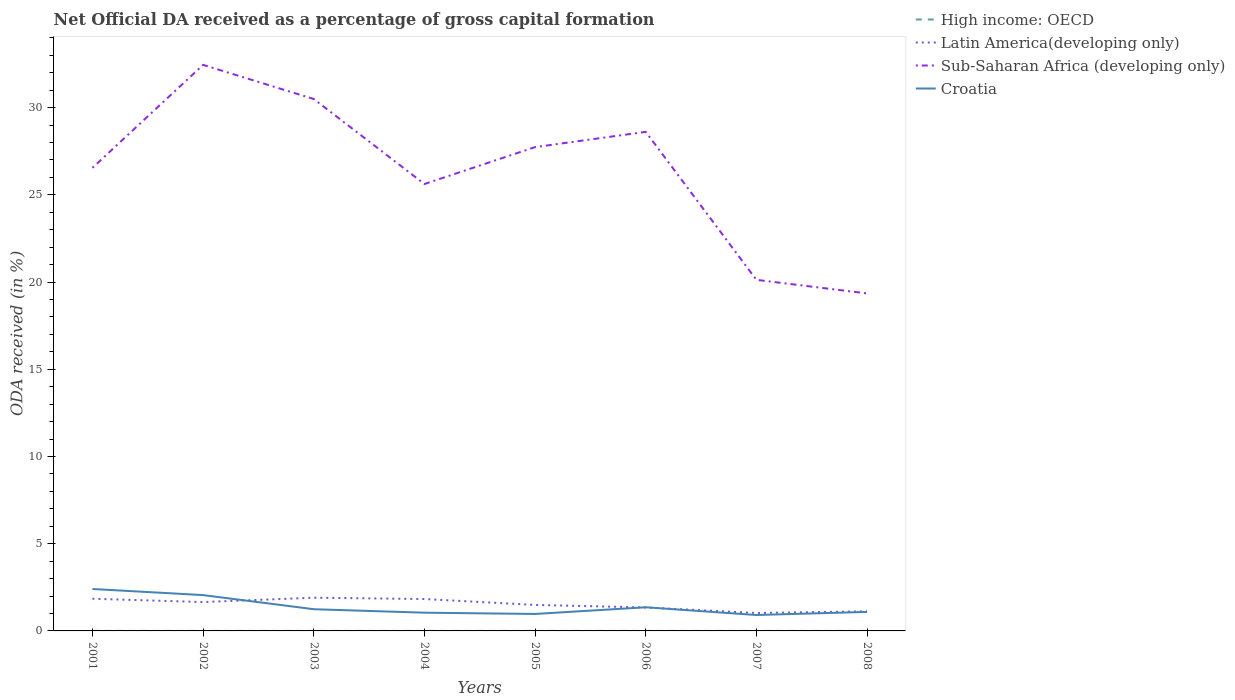How many different coloured lines are there?
Ensure brevity in your answer.  4. Is the number of lines equal to the number of legend labels?
Offer a terse response. Yes. Across all years, what is the maximum net ODA received in Croatia?
Provide a short and direct response. 0.91. In which year was the net ODA received in Latin America(developing only) maximum?
Make the answer very short. 2007. What is the total net ODA received in Croatia in the graph?
Your answer should be compact. 0.35. What is the difference between the highest and the second highest net ODA received in Latin America(developing only)?
Your answer should be compact. 0.88. Is the net ODA received in Croatia strictly greater than the net ODA received in Latin America(developing only) over the years?
Provide a short and direct response. No. How many years are there in the graph?
Keep it short and to the point. 8. What is the difference between two consecutive major ticks on the Y-axis?
Provide a short and direct response. 5. Are the values on the major ticks of Y-axis written in scientific E-notation?
Your response must be concise. No. Where does the legend appear in the graph?
Make the answer very short. Top right. What is the title of the graph?
Offer a very short reply. Net Official DA received as a percentage of gross capital formation. Does "Estonia" appear as one of the legend labels in the graph?
Give a very brief answer. No. What is the label or title of the X-axis?
Provide a short and direct response. Years. What is the label or title of the Y-axis?
Ensure brevity in your answer.  ODA received (in %). What is the ODA received (in %) in High income: OECD in 2001?
Ensure brevity in your answer.  0. What is the ODA received (in %) in Latin America(developing only) in 2001?
Provide a short and direct response. 1.84. What is the ODA received (in %) of Sub-Saharan Africa (developing only) in 2001?
Offer a terse response. 26.55. What is the ODA received (in %) of Croatia in 2001?
Give a very brief answer. 2.4. What is the ODA received (in %) in High income: OECD in 2002?
Offer a terse response. 0. What is the ODA received (in %) in Latin America(developing only) in 2002?
Your response must be concise. 1.65. What is the ODA received (in %) in Sub-Saharan Africa (developing only) in 2002?
Your answer should be very brief. 32.45. What is the ODA received (in %) in Croatia in 2002?
Give a very brief answer. 2.05. What is the ODA received (in %) of High income: OECD in 2003?
Offer a terse response. 0. What is the ODA received (in %) of Latin America(developing only) in 2003?
Offer a very short reply. 1.9. What is the ODA received (in %) of Sub-Saharan Africa (developing only) in 2003?
Offer a terse response. 30.5. What is the ODA received (in %) in Croatia in 2003?
Ensure brevity in your answer.  1.24. What is the ODA received (in %) of High income: OECD in 2004?
Your response must be concise. 0. What is the ODA received (in %) in Latin America(developing only) in 2004?
Offer a very short reply. 1.83. What is the ODA received (in %) in Sub-Saharan Africa (developing only) in 2004?
Keep it short and to the point. 25.62. What is the ODA received (in %) of Croatia in 2004?
Provide a short and direct response. 1.05. What is the ODA received (in %) of High income: OECD in 2005?
Your answer should be very brief. 0. What is the ODA received (in %) of Latin America(developing only) in 2005?
Your response must be concise. 1.49. What is the ODA received (in %) in Sub-Saharan Africa (developing only) in 2005?
Your response must be concise. 27.74. What is the ODA received (in %) in Croatia in 2005?
Give a very brief answer. 0.97. What is the ODA received (in %) of High income: OECD in 2006?
Your response must be concise. 0. What is the ODA received (in %) of Latin America(developing only) in 2006?
Offer a terse response. 1.34. What is the ODA received (in %) of Sub-Saharan Africa (developing only) in 2006?
Your answer should be compact. 28.61. What is the ODA received (in %) in Croatia in 2006?
Offer a terse response. 1.36. What is the ODA received (in %) of High income: OECD in 2007?
Your response must be concise. 0. What is the ODA received (in %) in Latin America(developing only) in 2007?
Your response must be concise. 1.03. What is the ODA received (in %) in Sub-Saharan Africa (developing only) in 2007?
Offer a terse response. 20.13. What is the ODA received (in %) of Croatia in 2007?
Your response must be concise. 0.91. What is the ODA received (in %) in High income: OECD in 2008?
Your answer should be very brief. 0. What is the ODA received (in %) of Latin America(developing only) in 2008?
Offer a very short reply. 1.12. What is the ODA received (in %) of Sub-Saharan Africa (developing only) in 2008?
Make the answer very short. 19.35. What is the ODA received (in %) in Croatia in 2008?
Your answer should be compact. 1.09. Across all years, what is the maximum ODA received (in %) in High income: OECD?
Give a very brief answer. 0. Across all years, what is the maximum ODA received (in %) of Latin America(developing only)?
Ensure brevity in your answer.  1.9. Across all years, what is the maximum ODA received (in %) in Sub-Saharan Africa (developing only)?
Give a very brief answer. 32.45. Across all years, what is the maximum ODA received (in %) in Croatia?
Provide a succinct answer. 2.4. Across all years, what is the minimum ODA received (in %) of High income: OECD?
Offer a terse response. 0. Across all years, what is the minimum ODA received (in %) of Latin America(developing only)?
Give a very brief answer. 1.03. Across all years, what is the minimum ODA received (in %) in Sub-Saharan Africa (developing only)?
Provide a succinct answer. 19.35. Across all years, what is the minimum ODA received (in %) in Croatia?
Offer a terse response. 0.91. What is the total ODA received (in %) in High income: OECD in the graph?
Your response must be concise. 0.01. What is the total ODA received (in %) of Latin America(developing only) in the graph?
Offer a terse response. 12.22. What is the total ODA received (in %) of Sub-Saharan Africa (developing only) in the graph?
Provide a succinct answer. 210.94. What is the total ODA received (in %) of Croatia in the graph?
Keep it short and to the point. 11.08. What is the difference between the ODA received (in %) of High income: OECD in 2001 and that in 2002?
Your answer should be compact. 0. What is the difference between the ODA received (in %) in Latin America(developing only) in 2001 and that in 2002?
Keep it short and to the point. 0.19. What is the difference between the ODA received (in %) in Sub-Saharan Africa (developing only) in 2001 and that in 2002?
Your answer should be compact. -5.9. What is the difference between the ODA received (in %) of Croatia in 2001 and that in 2002?
Offer a terse response. 0.35. What is the difference between the ODA received (in %) of High income: OECD in 2001 and that in 2003?
Your answer should be very brief. 0. What is the difference between the ODA received (in %) in Latin America(developing only) in 2001 and that in 2003?
Ensure brevity in your answer.  -0.06. What is the difference between the ODA received (in %) in Sub-Saharan Africa (developing only) in 2001 and that in 2003?
Keep it short and to the point. -3.95. What is the difference between the ODA received (in %) in Croatia in 2001 and that in 2003?
Your response must be concise. 1.16. What is the difference between the ODA received (in %) of High income: OECD in 2001 and that in 2004?
Provide a short and direct response. 0. What is the difference between the ODA received (in %) of Latin America(developing only) in 2001 and that in 2004?
Ensure brevity in your answer.  0.02. What is the difference between the ODA received (in %) of Sub-Saharan Africa (developing only) in 2001 and that in 2004?
Give a very brief answer. 0.93. What is the difference between the ODA received (in %) of Croatia in 2001 and that in 2004?
Offer a terse response. 1.36. What is the difference between the ODA received (in %) of High income: OECD in 2001 and that in 2005?
Provide a succinct answer. 0. What is the difference between the ODA received (in %) in Latin America(developing only) in 2001 and that in 2005?
Your answer should be compact. 0.35. What is the difference between the ODA received (in %) of Sub-Saharan Africa (developing only) in 2001 and that in 2005?
Give a very brief answer. -1.19. What is the difference between the ODA received (in %) in Croatia in 2001 and that in 2005?
Provide a short and direct response. 1.43. What is the difference between the ODA received (in %) in High income: OECD in 2001 and that in 2006?
Keep it short and to the point. 0. What is the difference between the ODA received (in %) of Sub-Saharan Africa (developing only) in 2001 and that in 2006?
Provide a succinct answer. -2.06. What is the difference between the ODA received (in %) in Croatia in 2001 and that in 2006?
Offer a very short reply. 1.05. What is the difference between the ODA received (in %) in High income: OECD in 2001 and that in 2007?
Provide a succinct answer. 0. What is the difference between the ODA received (in %) in Latin America(developing only) in 2001 and that in 2007?
Provide a succinct answer. 0.82. What is the difference between the ODA received (in %) in Sub-Saharan Africa (developing only) in 2001 and that in 2007?
Make the answer very short. 6.42. What is the difference between the ODA received (in %) of Croatia in 2001 and that in 2007?
Provide a succinct answer. 1.49. What is the difference between the ODA received (in %) in High income: OECD in 2001 and that in 2008?
Offer a terse response. 0. What is the difference between the ODA received (in %) of Latin America(developing only) in 2001 and that in 2008?
Make the answer very short. 0.72. What is the difference between the ODA received (in %) in Sub-Saharan Africa (developing only) in 2001 and that in 2008?
Provide a succinct answer. 7.2. What is the difference between the ODA received (in %) in Croatia in 2001 and that in 2008?
Your answer should be compact. 1.31. What is the difference between the ODA received (in %) in High income: OECD in 2002 and that in 2003?
Your answer should be compact. -0. What is the difference between the ODA received (in %) in Latin America(developing only) in 2002 and that in 2003?
Give a very brief answer. -0.25. What is the difference between the ODA received (in %) in Sub-Saharan Africa (developing only) in 2002 and that in 2003?
Offer a very short reply. 1.96. What is the difference between the ODA received (in %) of Croatia in 2002 and that in 2003?
Keep it short and to the point. 0.81. What is the difference between the ODA received (in %) in High income: OECD in 2002 and that in 2004?
Make the answer very short. 0. What is the difference between the ODA received (in %) of Latin America(developing only) in 2002 and that in 2004?
Provide a succinct answer. -0.17. What is the difference between the ODA received (in %) of Sub-Saharan Africa (developing only) in 2002 and that in 2004?
Give a very brief answer. 6.83. What is the difference between the ODA received (in %) in Croatia in 2002 and that in 2004?
Keep it short and to the point. 1.01. What is the difference between the ODA received (in %) in High income: OECD in 2002 and that in 2005?
Provide a short and direct response. -0. What is the difference between the ODA received (in %) of Latin America(developing only) in 2002 and that in 2005?
Your response must be concise. 0.16. What is the difference between the ODA received (in %) of Sub-Saharan Africa (developing only) in 2002 and that in 2005?
Offer a very short reply. 4.71. What is the difference between the ODA received (in %) of Croatia in 2002 and that in 2005?
Offer a terse response. 1.08. What is the difference between the ODA received (in %) of High income: OECD in 2002 and that in 2006?
Provide a succinct answer. -0. What is the difference between the ODA received (in %) in Latin America(developing only) in 2002 and that in 2006?
Make the answer very short. 0.31. What is the difference between the ODA received (in %) of Sub-Saharan Africa (developing only) in 2002 and that in 2006?
Keep it short and to the point. 3.84. What is the difference between the ODA received (in %) of Croatia in 2002 and that in 2006?
Provide a succinct answer. 0.7. What is the difference between the ODA received (in %) of High income: OECD in 2002 and that in 2007?
Offer a very short reply. -0. What is the difference between the ODA received (in %) in Latin America(developing only) in 2002 and that in 2007?
Your response must be concise. 0.63. What is the difference between the ODA received (in %) of Sub-Saharan Africa (developing only) in 2002 and that in 2007?
Keep it short and to the point. 12.32. What is the difference between the ODA received (in %) in Croatia in 2002 and that in 2007?
Offer a very short reply. 1.14. What is the difference between the ODA received (in %) in High income: OECD in 2002 and that in 2008?
Make the answer very short. -0. What is the difference between the ODA received (in %) in Latin America(developing only) in 2002 and that in 2008?
Offer a terse response. 0.53. What is the difference between the ODA received (in %) of Sub-Saharan Africa (developing only) in 2002 and that in 2008?
Your answer should be very brief. 13.1. What is the difference between the ODA received (in %) of Croatia in 2002 and that in 2008?
Offer a very short reply. 0.96. What is the difference between the ODA received (in %) of High income: OECD in 2003 and that in 2004?
Your answer should be very brief. 0. What is the difference between the ODA received (in %) in Latin America(developing only) in 2003 and that in 2004?
Keep it short and to the point. 0.08. What is the difference between the ODA received (in %) in Sub-Saharan Africa (developing only) in 2003 and that in 2004?
Your answer should be very brief. 4.87. What is the difference between the ODA received (in %) of Croatia in 2003 and that in 2004?
Offer a terse response. 0.2. What is the difference between the ODA received (in %) of High income: OECD in 2003 and that in 2005?
Offer a terse response. -0. What is the difference between the ODA received (in %) of Latin America(developing only) in 2003 and that in 2005?
Provide a short and direct response. 0.41. What is the difference between the ODA received (in %) in Sub-Saharan Africa (developing only) in 2003 and that in 2005?
Keep it short and to the point. 2.76. What is the difference between the ODA received (in %) in Croatia in 2003 and that in 2005?
Your answer should be very brief. 0.27. What is the difference between the ODA received (in %) in Latin America(developing only) in 2003 and that in 2006?
Your response must be concise. 0.56. What is the difference between the ODA received (in %) in Sub-Saharan Africa (developing only) in 2003 and that in 2006?
Offer a very short reply. 1.88. What is the difference between the ODA received (in %) in Croatia in 2003 and that in 2006?
Provide a short and direct response. -0.11. What is the difference between the ODA received (in %) of High income: OECD in 2003 and that in 2007?
Make the answer very short. 0. What is the difference between the ODA received (in %) in Latin America(developing only) in 2003 and that in 2007?
Offer a very short reply. 0.88. What is the difference between the ODA received (in %) in Sub-Saharan Africa (developing only) in 2003 and that in 2007?
Your answer should be very brief. 10.37. What is the difference between the ODA received (in %) in Croatia in 2003 and that in 2007?
Offer a terse response. 0.33. What is the difference between the ODA received (in %) of Latin America(developing only) in 2003 and that in 2008?
Offer a very short reply. 0.78. What is the difference between the ODA received (in %) of Sub-Saharan Africa (developing only) in 2003 and that in 2008?
Keep it short and to the point. 11.15. What is the difference between the ODA received (in %) of Croatia in 2003 and that in 2008?
Provide a short and direct response. 0.15. What is the difference between the ODA received (in %) of High income: OECD in 2004 and that in 2005?
Ensure brevity in your answer.  -0. What is the difference between the ODA received (in %) in Latin America(developing only) in 2004 and that in 2005?
Your answer should be compact. 0.34. What is the difference between the ODA received (in %) of Sub-Saharan Africa (developing only) in 2004 and that in 2005?
Offer a terse response. -2.12. What is the difference between the ODA received (in %) of Croatia in 2004 and that in 2005?
Offer a very short reply. 0.07. What is the difference between the ODA received (in %) of High income: OECD in 2004 and that in 2006?
Provide a short and direct response. -0. What is the difference between the ODA received (in %) of Latin America(developing only) in 2004 and that in 2006?
Your response must be concise. 0.48. What is the difference between the ODA received (in %) of Sub-Saharan Africa (developing only) in 2004 and that in 2006?
Your answer should be compact. -2.99. What is the difference between the ODA received (in %) of Croatia in 2004 and that in 2006?
Your answer should be compact. -0.31. What is the difference between the ODA received (in %) in High income: OECD in 2004 and that in 2007?
Ensure brevity in your answer.  -0. What is the difference between the ODA received (in %) in Latin America(developing only) in 2004 and that in 2007?
Make the answer very short. 0.8. What is the difference between the ODA received (in %) in Sub-Saharan Africa (developing only) in 2004 and that in 2007?
Provide a succinct answer. 5.49. What is the difference between the ODA received (in %) of Croatia in 2004 and that in 2007?
Give a very brief answer. 0.13. What is the difference between the ODA received (in %) of High income: OECD in 2004 and that in 2008?
Ensure brevity in your answer.  -0. What is the difference between the ODA received (in %) in Latin America(developing only) in 2004 and that in 2008?
Give a very brief answer. 0.71. What is the difference between the ODA received (in %) in Sub-Saharan Africa (developing only) in 2004 and that in 2008?
Your answer should be compact. 6.27. What is the difference between the ODA received (in %) in Croatia in 2004 and that in 2008?
Make the answer very short. -0.05. What is the difference between the ODA received (in %) in High income: OECD in 2005 and that in 2006?
Give a very brief answer. 0. What is the difference between the ODA received (in %) of Latin America(developing only) in 2005 and that in 2006?
Make the answer very short. 0.15. What is the difference between the ODA received (in %) of Sub-Saharan Africa (developing only) in 2005 and that in 2006?
Offer a very short reply. -0.88. What is the difference between the ODA received (in %) in Croatia in 2005 and that in 2006?
Keep it short and to the point. -0.38. What is the difference between the ODA received (in %) of High income: OECD in 2005 and that in 2007?
Offer a very short reply. 0. What is the difference between the ODA received (in %) of Latin America(developing only) in 2005 and that in 2007?
Make the answer very short. 0.46. What is the difference between the ODA received (in %) in Sub-Saharan Africa (developing only) in 2005 and that in 2007?
Your response must be concise. 7.61. What is the difference between the ODA received (in %) of Croatia in 2005 and that in 2007?
Your answer should be very brief. 0.06. What is the difference between the ODA received (in %) of High income: OECD in 2005 and that in 2008?
Your answer should be very brief. 0. What is the difference between the ODA received (in %) of Latin America(developing only) in 2005 and that in 2008?
Provide a succinct answer. 0.37. What is the difference between the ODA received (in %) of Sub-Saharan Africa (developing only) in 2005 and that in 2008?
Offer a very short reply. 8.39. What is the difference between the ODA received (in %) of Croatia in 2005 and that in 2008?
Your answer should be very brief. -0.12. What is the difference between the ODA received (in %) in High income: OECD in 2006 and that in 2007?
Make the answer very short. 0. What is the difference between the ODA received (in %) of Latin America(developing only) in 2006 and that in 2007?
Offer a very short reply. 0.32. What is the difference between the ODA received (in %) in Sub-Saharan Africa (developing only) in 2006 and that in 2007?
Provide a succinct answer. 8.48. What is the difference between the ODA received (in %) of Croatia in 2006 and that in 2007?
Offer a terse response. 0.44. What is the difference between the ODA received (in %) of Latin America(developing only) in 2006 and that in 2008?
Offer a terse response. 0.22. What is the difference between the ODA received (in %) of Sub-Saharan Africa (developing only) in 2006 and that in 2008?
Your response must be concise. 9.26. What is the difference between the ODA received (in %) of Croatia in 2006 and that in 2008?
Your answer should be very brief. 0.26. What is the difference between the ODA received (in %) in High income: OECD in 2007 and that in 2008?
Make the answer very short. 0. What is the difference between the ODA received (in %) of Latin America(developing only) in 2007 and that in 2008?
Offer a very short reply. -0.09. What is the difference between the ODA received (in %) in Sub-Saharan Africa (developing only) in 2007 and that in 2008?
Your answer should be compact. 0.78. What is the difference between the ODA received (in %) of Croatia in 2007 and that in 2008?
Keep it short and to the point. -0.18. What is the difference between the ODA received (in %) of High income: OECD in 2001 and the ODA received (in %) of Latin America(developing only) in 2002?
Keep it short and to the point. -1.65. What is the difference between the ODA received (in %) in High income: OECD in 2001 and the ODA received (in %) in Sub-Saharan Africa (developing only) in 2002?
Provide a succinct answer. -32.45. What is the difference between the ODA received (in %) in High income: OECD in 2001 and the ODA received (in %) in Croatia in 2002?
Your response must be concise. -2.05. What is the difference between the ODA received (in %) of Latin America(developing only) in 2001 and the ODA received (in %) of Sub-Saharan Africa (developing only) in 2002?
Offer a terse response. -30.61. What is the difference between the ODA received (in %) in Latin America(developing only) in 2001 and the ODA received (in %) in Croatia in 2002?
Make the answer very short. -0.21. What is the difference between the ODA received (in %) of Sub-Saharan Africa (developing only) in 2001 and the ODA received (in %) of Croatia in 2002?
Provide a short and direct response. 24.49. What is the difference between the ODA received (in %) of High income: OECD in 2001 and the ODA received (in %) of Latin America(developing only) in 2003?
Make the answer very short. -1.9. What is the difference between the ODA received (in %) of High income: OECD in 2001 and the ODA received (in %) of Sub-Saharan Africa (developing only) in 2003?
Make the answer very short. -30.49. What is the difference between the ODA received (in %) of High income: OECD in 2001 and the ODA received (in %) of Croatia in 2003?
Ensure brevity in your answer.  -1.24. What is the difference between the ODA received (in %) in Latin America(developing only) in 2001 and the ODA received (in %) in Sub-Saharan Africa (developing only) in 2003?
Your answer should be compact. -28.65. What is the difference between the ODA received (in %) of Sub-Saharan Africa (developing only) in 2001 and the ODA received (in %) of Croatia in 2003?
Offer a terse response. 25.3. What is the difference between the ODA received (in %) of High income: OECD in 2001 and the ODA received (in %) of Latin America(developing only) in 2004?
Give a very brief answer. -1.82. What is the difference between the ODA received (in %) of High income: OECD in 2001 and the ODA received (in %) of Sub-Saharan Africa (developing only) in 2004?
Keep it short and to the point. -25.62. What is the difference between the ODA received (in %) of High income: OECD in 2001 and the ODA received (in %) of Croatia in 2004?
Provide a short and direct response. -1.04. What is the difference between the ODA received (in %) in Latin America(developing only) in 2001 and the ODA received (in %) in Sub-Saharan Africa (developing only) in 2004?
Ensure brevity in your answer.  -23.78. What is the difference between the ODA received (in %) of Latin America(developing only) in 2001 and the ODA received (in %) of Croatia in 2004?
Give a very brief answer. 0.8. What is the difference between the ODA received (in %) in Sub-Saharan Africa (developing only) in 2001 and the ODA received (in %) in Croatia in 2004?
Ensure brevity in your answer.  25.5. What is the difference between the ODA received (in %) in High income: OECD in 2001 and the ODA received (in %) in Latin America(developing only) in 2005?
Offer a terse response. -1.49. What is the difference between the ODA received (in %) of High income: OECD in 2001 and the ODA received (in %) of Sub-Saharan Africa (developing only) in 2005?
Make the answer very short. -27.73. What is the difference between the ODA received (in %) in High income: OECD in 2001 and the ODA received (in %) in Croatia in 2005?
Keep it short and to the point. -0.97. What is the difference between the ODA received (in %) in Latin America(developing only) in 2001 and the ODA received (in %) in Sub-Saharan Africa (developing only) in 2005?
Make the answer very short. -25.89. What is the difference between the ODA received (in %) in Latin America(developing only) in 2001 and the ODA received (in %) in Croatia in 2005?
Offer a very short reply. 0.87. What is the difference between the ODA received (in %) in Sub-Saharan Africa (developing only) in 2001 and the ODA received (in %) in Croatia in 2005?
Your answer should be very brief. 25.58. What is the difference between the ODA received (in %) in High income: OECD in 2001 and the ODA received (in %) in Latin America(developing only) in 2006?
Give a very brief answer. -1.34. What is the difference between the ODA received (in %) of High income: OECD in 2001 and the ODA received (in %) of Sub-Saharan Africa (developing only) in 2006?
Provide a succinct answer. -28.61. What is the difference between the ODA received (in %) in High income: OECD in 2001 and the ODA received (in %) in Croatia in 2006?
Give a very brief answer. -1.35. What is the difference between the ODA received (in %) of Latin America(developing only) in 2001 and the ODA received (in %) of Sub-Saharan Africa (developing only) in 2006?
Your answer should be compact. -26.77. What is the difference between the ODA received (in %) of Latin America(developing only) in 2001 and the ODA received (in %) of Croatia in 2006?
Ensure brevity in your answer.  0.49. What is the difference between the ODA received (in %) in Sub-Saharan Africa (developing only) in 2001 and the ODA received (in %) in Croatia in 2006?
Make the answer very short. 25.19. What is the difference between the ODA received (in %) of High income: OECD in 2001 and the ODA received (in %) of Latin America(developing only) in 2007?
Offer a terse response. -1.02. What is the difference between the ODA received (in %) of High income: OECD in 2001 and the ODA received (in %) of Sub-Saharan Africa (developing only) in 2007?
Ensure brevity in your answer.  -20.12. What is the difference between the ODA received (in %) of High income: OECD in 2001 and the ODA received (in %) of Croatia in 2007?
Your answer should be very brief. -0.91. What is the difference between the ODA received (in %) in Latin America(developing only) in 2001 and the ODA received (in %) in Sub-Saharan Africa (developing only) in 2007?
Provide a succinct answer. -18.28. What is the difference between the ODA received (in %) in Latin America(developing only) in 2001 and the ODA received (in %) in Croatia in 2007?
Provide a succinct answer. 0.93. What is the difference between the ODA received (in %) in Sub-Saharan Africa (developing only) in 2001 and the ODA received (in %) in Croatia in 2007?
Keep it short and to the point. 25.64. What is the difference between the ODA received (in %) in High income: OECD in 2001 and the ODA received (in %) in Latin America(developing only) in 2008?
Offer a very short reply. -1.12. What is the difference between the ODA received (in %) in High income: OECD in 2001 and the ODA received (in %) in Sub-Saharan Africa (developing only) in 2008?
Give a very brief answer. -19.35. What is the difference between the ODA received (in %) of High income: OECD in 2001 and the ODA received (in %) of Croatia in 2008?
Keep it short and to the point. -1.09. What is the difference between the ODA received (in %) in Latin America(developing only) in 2001 and the ODA received (in %) in Sub-Saharan Africa (developing only) in 2008?
Your answer should be very brief. -17.5. What is the difference between the ODA received (in %) in Latin America(developing only) in 2001 and the ODA received (in %) in Croatia in 2008?
Offer a terse response. 0.75. What is the difference between the ODA received (in %) in Sub-Saharan Africa (developing only) in 2001 and the ODA received (in %) in Croatia in 2008?
Your answer should be very brief. 25.46. What is the difference between the ODA received (in %) of High income: OECD in 2002 and the ODA received (in %) of Latin America(developing only) in 2003?
Keep it short and to the point. -1.9. What is the difference between the ODA received (in %) in High income: OECD in 2002 and the ODA received (in %) in Sub-Saharan Africa (developing only) in 2003?
Offer a terse response. -30.5. What is the difference between the ODA received (in %) of High income: OECD in 2002 and the ODA received (in %) of Croatia in 2003?
Provide a short and direct response. -1.24. What is the difference between the ODA received (in %) of Latin America(developing only) in 2002 and the ODA received (in %) of Sub-Saharan Africa (developing only) in 2003?
Offer a very short reply. -28.84. What is the difference between the ODA received (in %) in Latin America(developing only) in 2002 and the ODA received (in %) in Croatia in 2003?
Ensure brevity in your answer.  0.41. What is the difference between the ODA received (in %) of Sub-Saharan Africa (developing only) in 2002 and the ODA received (in %) of Croatia in 2003?
Offer a very short reply. 31.21. What is the difference between the ODA received (in %) of High income: OECD in 2002 and the ODA received (in %) of Latin America(developing only) in 2004?
Your answer should be very brief. -1.83. What is the difference between the ODA received (in %) in High income: OECD in 2002 and the ODA received (in %) in Sub-Saharan Africa (developing only) in 2004?
Provide a succinct answer. -25.62. What is the difference between the ODA received (in %) of High income: OECD in 2002 and the ODA received (in %) of Croatia in 2004?
Offer a very short reply. -1.04. What is the difference between the ODA received (in %) in Latin America(developing only) in 2002 and the ODA received (in %) in Sub-Saharan Africa (developing only) in 2004?
Provide a short and direct response. -23.97. What is the difference between the ODA received (in %) in Latin America(developing only) in 2002 and the ODA received (in %) in Croatia in 2004?
Provide a short and direct response. 0.61. What is the difference between the ODA received (in %) of Sub-Saharan Africa (developing only) in 2002 and the ODA received (in %) of Croatia in 2004?
Offer a terse response. 31.41. What is the difference between the ODA received (in %) in High income: OECD in 2002 and the ODA received (in %) in Latin America(developing only) in 2005?
Provide a succinct answer. -1.49. What is the difference between the ODA received (in %) in High income: OECD in 2002 and the ODA received (in %) in Sub-Saharan Africa (developing only) in 2005?
Your answer should be very brief. -27.74. What is the difference between the ODA received (in %) of High income: OECD in 2002 and the ODA received (in %) of Croatia in 2005?
Make the answer very short. -0.97. What is the difference between the ODA received (in %) of Latin America(developing only) in 2002 and the ODA received (in %) of Sub-Saharan Africa (developing only) in 2005?
Your answer should be very brief. -26.08. What is the difference between the ODA received (in %) of Latin America(developing only) in 2002 and the ODA received (in %) of Croatia in 2005?
Provide a short and direct response. 0.68. What is the difference between the ODA received (in %) of Sub-Saharan Africa (developing only) in 2002 and the ODA received (in %) of Croatia in 2005?
Your answer should be compact. 31.48. What is the difference between the ODA received (in %) in High income: OECD in 2002 and the ODA received (in %) in Latin America(developing only) in 2006?
Ensure brevity in your answer.  -1.34. What is the difference between the ODA received (in %) of High income: OECD in 2002 and the ODA received (in %) of Sub-Saharan Africa (developing only) in 2006?
Offer a very short reply. -28.61. What is the difference between the ODA received (in %) of High income: OECD in 2002 and the ODA received (in %) of Croatia in 2006?
Offer a very short reply. -1.35. What is the difference between the ODA received (in %) in Latin America(developing only) in 2002 and the ODA received (in %) in Sub-Saharan Africa (developing only) in 2006?
Provide a short and direct response. -26.96. What is the difference between the ODA received (in %) in Latin America(developing only) in 2002 and the ODA received (in %) in Croatia in 2006?
Your response must be concise. 0.3. What is the difference between the ODA received (in %) in Sub-Saharan Africa (developing only) in 2002 and the ODA received (in %) in Croatia in 2006?
Offer a terse response. 31.1. What is the difference between the ODA received (in %) of High income: OECD in 2002 and the ODA received (in %) of Latin America(developing only) in 2007?
Give a very brief answer. -1.03. What is the difference between the ODA received (in %) in High income: OECD in 2002 and the ODA received (in %) in Sub-Saharan Africa (developing only) in 2007?
Offer a very short reply. -20.13. What is the difference between the ODA received (in %) of High income: OECD in 2002 and the ODA received (in %) of Croatia in 2007?
Offer a terse response. -0.91. What is the difference between the ODA received (in %) of Latin America(developing only) in 2002 and the ODA received (in %) of Sub-Saharan Africa (developing only) in 2007?
Offer a terse response. -18.47. What is the difference between the ODA received (in %) of Latin America(developing only) in 2002 and the ODA received (in %) of Croatia in 2007?
Provide a succinct answer. 0.74. What is the difference between the ODA received (in %) in Sub-Saharan Africa (developing only) in 2002 and the ODA received (in %) in Croatia in 2007?
Keep it short and to the point. 31.54. What is the difference between the ODA received (in %) of High income: OECD in 2002 and the ODA received (in %) of Latin America(developing only) in 2008?
Your answer should be very brief. -1.12. What is the difference between the ODA received (in %) of High income: OECD in 2002 and the ODA received (in %) of Sub-Saharan Africa (developing only) in 2008?
Ensure brevity in your answer.  -19.35. What is the difference between the ODA received (in %) in High income: OECD in 2002 and the ODA received (in %) in Croatia in 2008?
Offer a terse response. -1.09. What is the difference between the ODA received (in %) of Latin America(developing only) in 2002 and the ODA received (in %) of Sub-Saharan Africa (developing only) in 2008?
Your response must be concise. -17.69. What is the difference between the ODA received (in %) of Latin America(developing only) in 2002 and the ODA received (in %) of Croatia in 2008?
Make the answer very short. 0.56. What is the difference between the ODA received (in %) in Sub-Saharan Africa (developing only) in 2002 and the ODA received (in %) in Croatia in 2008?
Provide a succinct answer. 31.36. What is the difference between the ODA received (in %) of High income: OECD in 2003 and the ODA received (in %) of Latin America(developing only) in 2004?
Your response must be concise. -1.83. What is the difference between the ODA received (in %) in High income: OECD in 2003 and the ODA received (in %) in Sub-Saharan Africa (developing only) in 2004?
Your answer should be compact. -25.62. What is the difference between the ODA received (in %) of High income: OECD in 2003 and the ODA received (in %) of Croatia in 2004?
Offer a terse response. -1.04. What is the difference between the ODA received (in %) in Latin America(developing only) in 2003 and the ODA received (in %) in Sub-Saharan Africa (developing only) in 2004?
Offer a terse response. -23.72. What is the difference between the ODA received (in %) of Latin America(developing only) in 2003 and the ODA received (in %) of Croatia in 2004?
Make the answer very short. 0.86. What is the difference between the ODA received (in %) in Sub-Saharan Africa (developing only) in 2003 and the ODA received (in %) in Croatia in 2004?
Your response must be concise. 29.45. What is the difference between the ODA received (in %) of High income: OECD in 2003 and the ODA received (in %) of Latin America(developing only) in 2005?
Your answer should be very brief. -1.49. What is the difference between the ODA received (in %) of High income: OECD in 2003 and the ODA received (in %) of Sub-Saharan Africa (developing only) in 2005?
Give a very brief answer. -27.74. What is the difference between the ODA received (in %) in High income: OECD in 2003 and the ODA received (in %) in Croatia in 2005?
Provide a short and direct response. -0.97. What is the difference between the ODA received (in %) in Latin America(developing only) in 2003 and the ODA received (in %) in Sub-Saharan Africa (developing only) in 2005?
Provide a succinct answer. -25.83. What is the difference between the ODA received (in %) in Latin America(developing only) in 2003 and the ODA received (in %) in Croatia in 2005?
Keep it short and to the point. 0.93. What is the difference between the ODA received (in %) of Sub-Saharan Africa (developing only) in 2003 and the ODA received (in %) of Croatia in 2005?
Your response must be concise. 29.52. What is the difference between the ODA received (in %) of High income: OECD in 2003 and the ODA received (in %) of Latin America(developing only) in 2006?
Offer a very short reply. -1.34. What is the difference between the ODA received (in %) of High income: OECD in 2003 and the ODA received (in %) of Sub-Saharan Africa (developing only) in 2006?
Your answer should be very brief. -28.61. What is the difference between the ODA received (in %) of High income: OECD in 2003 and the ODA received (in %) of Croatia in 2006?
Your response must be concise. -1.35. What is the difference between the ODA received (in %) of Latin America(developing only) in 2003 and the ODA received (in %) of Sub-Saharan Africa (developing only) in 2006?
Offer a very short reply. -26.71. What is the difference between the ODA received (in %) in Latin America(developing only) in 2003 and the ODA received (in %) in Croatia in 2006?
Offer a terse response. 0.55. What is the difference between the ODA received (in %) of Sub-Saharan Africa (developing only) in 2003 and the ODA received (in %) of Croatia in 2006?
Make the answer very short. 29.14. What is the difference between the ODA received (in %) in High income: OECD in 2003 and the ODA received (in %) in Latin America(developing only) in 2007?
Ensure brevity in your answer.  -1.03. What is the difference between the ODA received (in %) of High income: OECD in 2003 and the ODA received (in %) of Sub-Saharan Africa (developing only) in 2007?
Offer a very short reply. -20.13. What is the difference between the ODA received (in %) in High income: OECD in 2003 and the ODA received (in %) in Croatia in 2007?
Your answer should be compact. -0.91. What is the difference between the ODA received (in %) in Latin America(developing only) in 2003 and the ODA received (in %) in Sub-Saharan Africa (developing only) in 2007?
Your answer should be compact. -18.22. What is the difference between the ODA received (in %) in Sub-Saharan Africa (developing only) in 2003 and the ODA received (in %) in Croatia in 2007?
Keep it short and to the point. 29.58. What is the difference between the ODA received (in %) of High income: OECD in 2003 and the ODA received (in %) of Latin America(developing only) in 2008?
Offer a terse response. -1.12. What is the difference between the ODA received (in %) of High income: OECD in 2003 and the ODA received (in %) of Sub-Saharan Africa (developing only) in 2008?
Offer a terse response. -19.35. What is the difference between the ODA received (in %) of High income: OECD in 2003 and the ODA received (in %) of Croatia in 2008?
Offer a terse response. -1.09. What is the difference between the ODA received (in %) in Latin America(developing only) in 2003 and the ODA received (in %) in Sub-Saharan Africa (developing only) in 2008?
Provide a short and direct response. -17.44. What is the difference between the ODA received (in %) in Latin America(developing only) in 2003 and the ODA received (in %) in Croatia in 2008?
Offer a terse response. 0.81. What is the difference between the ODA received (in %) of Sub-Saharan Africa (developing only) in 2003 and the ODA received (in %) of Croatia in 2008?
Offer a very short reply. 29.41. What is the difference between the ODA received (in %) of High income: OECD in 2004 and the ODA received (in %) of Latin America(developing only) in 2005?
Your answer should be very brief. -1.49. What is the difference between the ODA received (in %) of High income: OECD in 2004 and the ODA received (in %) of Sub-Saharan Africa (developing only) in 2005?
Provide a short and direct response. -27.74. What is the difference between the ODA received (in %) in High income: OECD in 2004 and the ODA received (in %) in Croatia in 2005?
Offer a very short reply. -0.97. What is the difference between the ODA received (in %) in Latin America(developing only) in 2004 and the ODA received (in %) in Sub-Saharan Africa (developing only) in 2005?
Your answer should be compact. -25.91. What is the difference between the ODA received (in %) in Latin America(developing only) in 2004 and the ODA received (in %) in Croatia in 2005?
Offer a terse response. 0.85. What is the difference between the ODA received (in %) of Sub-Saharan Africa (developing only) in 2004 and the ODA received (in %) of Croatia in 2005?
Provide a succinct answer. 24.65. What is the difference between the ODA received (in %) in High income: OECD in 2004 and the ODA received (in %) in Latin America(developing only) in 2006?
Your answer should be very brief. -1.34. What is the difference between the ODA received (in %) of High income: OECD in 2004 and the ODA received (in %) of Sub-Saharan Africa (developing only) in 2006?
Ensure brevity in your answer.  -28.61. What is the difference between the ODA received (in %) of High income: OECD in 2004 and the ODA received (in %) of Croatia in 2006?
Offer a terse response. -1.35. What is the difference between the ODA received (in %) in Latin America(developing only) in 2004 and the ODA received (in %) in Sub-Saharan Africa (developing only) in 2006?
Offer a very short reply. -26.78. What is the difference between the ODA received (in %) in Latin America(developing only) in 2004 and the ODA received (in %) in Croatia in 2006?
Provide a short and direct response. 0.47. What is the difference between the ODA received (in %) in Sub-Saharan Africa (developing only) in 2004 and the ODA received (in %) in Croatia in 2006?
Offer a very short reply. 24.27. What is the difference between the ODA received (in %) of High income: OECD in 2004 and the ODA received (in %) of Latin America(developing only) in 2007?
Give a very brief answer. -1.03. What is the difference between the ODA received (in %) of High income: OECD in 2004 and the ODA received (in %) of Sub-Saharan Africa (developing only) in 2007?
Keep it short and to the point. -20.13. What is the difference between the ODA received (in %) in High income: OECD in 2004 and the ODA received (in %) in Croatia in 2007?
Your response must be concise. -0.91. What is the difference between the ODA received (in %) of Latin America(developing only) in 2004 and the ODA received (in %) of Sub-Saharan Africa (developing only) in 2007?
Your answer should be compact. -18.3. What is the difference between the ODA received (in %) in Latin America(developing only) in 2004 and the ODA received (in %) in Croatia in 2007?
Your answer should be very brief. 0.91. What is the difference between the ODA received (in %) of Sub-Saharan Africa (developing only) in 2004 and the ODA received (in %) of Croatia in 2007?
Your answer should be very brief. 24.71. What is the difference between the ODA received (in %) in High income: OECD in 2004 and the ODA received (in %) in Latin America(developing only) in 2008?
Your answer should be very brief. -1.12. What is the difference between the ODA received (in %) of High income: OECD in 2004 and the ODA received (in %) of Sub-Saharan Africa (developing only) in 2008?
Your answer should be compact. -19.35. What is the difference between the ODA received (in %) of High income: OECD in 2004 and the ODA received (in %) of Croatia in 2008?
Keep it short and to the point. -1.09. What is the difference between the ODA received (in %) in Latin America(developing only) in 2004 and the ODA received (in %) in Sub-Saharan Africa (developing only) in 2008?
Your response must be concise. -17.52. What is the difference between the ODA received (in %) of Latin America(developing only) in 2004 and the ODA received (in %) of Croatia in 2008?
Provide a short and direct response. 0.74. What is the difference between the ODA received (in %) in Sub-Saharan Africa (developing only) in 2004 and the ODA received (in %) in Croatia in 2008?
Your answer should be very brief. 24.53. What is the difference between the ODA received (in %) of High income: OECD in 2005 and the ODA received (in %) of Latin America(developing only) in 2006?
Ensure brevity in your answer.  -1.34. What is the difference between the ODA received (in %) of High income: OECD in 2005 and the ODA received (in %) of Sub-Saharan Africa (developing only) in 2006?
Provide a short and direct response. -28.61. What is the difference between the ODA received (in %) of High income: OECD in 2005 and the ODA received (in %) of Croatia in 2006?
Your answer should be compact. -1.35. What is the difference between the ODA received (in %) in Latin America(developing only) in 2005 and the ODA received (in %) in Sub-Saharan Africa (developing only) in 2006?
Your answer should be very brief. -27.12. What is the difference between the ODA received (in %) in Latin America(developing only) in 2005 and the ODA received (in %) in Croatia in 2006?
Offer a terse response. 0.14. What is the difference between the ODA received (in %) in Sub-Saharan Africa (developing only) in 2005 and the ODA received (in %) in Croatia in 2006?
Make the answer very short. 26.38. What is the difference between the ODA received (in %) of High income: OECD in 2005 and the ODA received (in %) of Latin America(developing only) in 2007?
Ensure brevity in your answer.  -1.03. What is the difference between the ODA received (in %) of High income: OECD in 2005 and the ODA received (in %) of Sub-Saharan Africa (developing only) in 2007?
Your answer should be very brief. -20.13. What is the difference between the ODA received (in %) of High income: OECD in 2005 and the ODA received (in %) of Croatia in 2007?
Your answer should be compact. -0.91. What is the difference between the ODA received (in %) in Latin America(developing only) in 2005 and the ODA received (in %) in Sub-Saharan Africa (developing only) in 2007?
Your answer should be compact. -18.64. What is the difference between the ODA received (in %) in Latin America(developing only) in 2005 and the ODA received (in %) in Croatia in 2007?
Ensure brevity in your answer.  0.58. What is the difference between the ODA received (in %) of Sub-Saharan Africa (developing only) in 2005 and the ODA received (in %) of Croatia in 2007?
Offer a very short reply. 26.82. What is the difference between the ODA received (in %) in High income: OECD in 2005 and the ODA received (in %) in Latin America(developing only) in 2008?
Give a very brief answer. -1.12. What is the difference between the ODA received (in %) of High income: OECD in 2005 and the ODA received (in %) of Sub-Saharan Africa (developing only) in 2008?
Offer a very short reply. -19.35. What is the difference between the ODA received (in %) of High income: OECD in 2005 and the ODA received (in %) of Croatia in 2008?
Offer a terse response. -1.09. What is the difference between the ODA received (in %) of Latin America(developing only) in 2005 and the ODA received (in %) of Sub-Saharan Africa (developing only) in 2008?
Your answer should be compact. -17.86. What is the difference between the ODA received (in %) of Latin America(developing only) in 2005 and the ODA received (in %) of Croatia in 2008?
Provide a short and direct response. 0.4. What is the difference between the ODA received (in %) of Sub-Saharan Africa (developing only) in 2005 and the ODA received (in %) of Croatia in 2008?
Your response must be concise. 26.65. What is the difference between the ODA received (in %) of High income: OECD in 2006 and the ODA received (in %) of Latin America(developing only) in 2007?
Provide a short and direct response. -1.03. What is the difference between the ODA received (in %) in High income: OECD in 2006 and the ODA received (in %) in Sub-Saharan Africa (developing only) in 2007?
Make the answer very short. -20.13. What is the difference between the ODA received (in %) of High income: OECD in 2006 and the ODA received (in %) of Croatia in 2007?
Your answer should be compact. -0.91. What is the difference between the ODA received (in %) in Latin America(developing only) in 2006 and the ODA received (in %) in Sub-Saharan Africa (developing only) in 2007?
Offer a terse response. -18.78. What is the difference between the ODA received (in %) in Latin America(developing only) in 2006 and the ODA received (in %) in Croatia in 2007?
Provide a succinct answer. 0.43. What is the difference between the ODA received (in %) of Sub-Saharan Africa (developing only) in 2006 and the ODA received (in %) of Croatia in 2007?
Provide a succinct answer. 27.7. What is the difference between the ODA received (in %) of High income: OECD in 2006 and the ODA received (in %) of Latin America(developing only) in 2008?
Your answer should be very brief. -1.12. What is the difference between the ODA received (in %) of High income: OECD in 2006 and the ODA received (in %) of Sub-Saharan Africa (developing only) in 2008?
Your answer should be very brief. -19.35. What is the difference between the ODA received (in %) of High income: OECD in 2006 and the ODA received (in %) of Croatia in 2008?
Ensure brevity in your answer.  -1.09. What is the difference between the ODA received (in %) of Latin America(developing only) in 2006 and the ODA received (in %) of Sub-Saharan Africa (developing only) in 2008?
Keep it short and to the point. -18. What is the difference between the ODA received (in %) of Latin America(developing only) in 2006 and the ODA received (in %) of Croatia in 2008?
Keep it short and to the point. 0.25. What is the difference between the ODA received (in %) of Sub-Saharan Africa (developing only) in 2006 and the ODA received (in %) of Croatia in 2008?
Give a very brief answer. 27.52. What is the difference between the ODA received (in %) in High income: OECD in 2007 and the ODA received (in %) in Latin America(developing only) in 2008?
Provide a short and direct response. -1.12. What is the difference between the ODA received (in %) of High income: OECD in 2007 and the ODA received (in %) of Sub-Saharan Africa (developing only) in 2008?
Give a very brief answer. -19.35. What is the difference between the ODA received (in %) of High income: OECD in 2007 and the ODA received (in %) of Croatia in 2008?
Keep it short and to the point. -1.09. What is the difference between the ODA received (in %) of Latin America(developing only) in 2007 and the ODA received (in %) of Sub-Saharan Africa (developing only) in 2008?
Ensure brevity in your answer.  -18.32. What is the difference between the ODA received (in %) in Latin America(developing only) in 2007 and the ODA received (in %) in Croatia in 2008?
Keep it short and to the point. -0.06. What is the difference between the ODA received (in %) of Sub-Saharan Africa (developing only) in 2007 and the ODA received (in %) of Croatia in 2008?
Offer a terse response. 19.04. What is the average ODA received (in %) in High income: OECD per year?
Provide a short and direct response. 0. What is the average ODA received (in %) of Latin America(developing only) per year?
Provide a succinct answer. 1.53. What is the average ODA received (in %) in Sub-Saharan Africa (developing only) per year?
Ensure brevity in your answer.  26.37. What is the average ODA received (in %) of Croatia per year?
Provide a short and direct response. 1.38. In the year 2001, what is the difference between the ODA received (in %) in High income: OECD and ODA received (in %) in Latin America(developing only)?
Give a very brief answer. -1.84. In the year 2001, what is the difference between the ODA received (in %) in High income: OECD and ODA received (in %) in Sub-Saharan Africa (developing only)?
Your answer should be very brief. -26.54. In the year 2001, what is the difference between the ODA received (in %) in High income: OECD and ODA received (in %) in Croatia?
Your answer should be compact. -2.4. In the year 2001, what is the difference between the ODA received (in %) in Latin America(developing only) and ODA received (in %) in Sub-Saharan Africa (developing only)?
Offer a terse response. -24.7. In the year 2001, what is the difference between the ODA received (in %) of Latin America(developing only) and ODA received (in %) of Croatia?
Your answer should be very brief. -0.56. In the year 2001, what is the difference between the ODA received (in %) of Sub-Saharan Africa (developing only) and ODA received (in %) of Croatia?
Your answer should be compact. 24.14. In the year 2002, what is the difference between the ODA received (in %) of High income: OECD and ODA received (in %) of Latin America(developing only)?
Provide a short and direct response. -1.65. In the year 2002, what is the difference between the ODA received (in %) in High income: OECD and ODA received (in %) in Sub-Saharan Africa (developing only)?
Keep it short and to the point. -32.45. In the year 2002, what is the difference between the ODA received (in %) of High income: OECD and ODA received (in %) of Croatia?
Your answer should be very brief. -2.05. In the year 2002, what is the difference between the ODA received (in %) in Latin America(developing only) and ODA received (in %) in Sub-Saharan Africa (developing only)?
Provide a succinct answer. -30.8. In the year 2002, what is the difference between the ODA received (in %) in Latin America(developing only) and ODA received (in %) in Croatia?
Your response must be concise. -0.4. In the year 2002, what is the difference between the ODA received (in %) of Sub-Saharan Africa (developing only) and ODA received (in %) of Croatia?
Make the answer very short. 30.4. In the year 2003, what is the difference between the ODA received (in %) of High income: OECD and ODA received (in %) of Latin America(developing only)?
Keep it short and to the point. -1.9. In the year 2003, what is the difference between the ODA received (in %) in High income: OECD and ODA received (in %) in Sub-Saharan Africa (developing only)?
Your response must be concise. -30.49. In the year 2003, what is the difference between the ODA received (in %) of High income: OECD and ODA received (in %) of Croatia?
Provide a succinct answer. -1.24. In the year 2003, what is the difference between the ODA received (in %) in Latin America(developing only) and ODA received (in %) in Sub-Saharan Africa (developing only)?
Your answer should be compact. -28.59. In the year 2003, what is the difference between the ODA received (in %) in Latin America(developing only) and ODA received (in %) in Croatia?
Make the answer very short. 0.66. In the year 2003, what is the difference between the ODA received (in %) in Sub-Saharan Africa (developing only) and ODA received (in %) in Croatia?
Provide a succinct answer. 29.25. In the year 2004, what is the difference between the ODA received (in %) in High income: OECD and ODA received (in %) in Latin America(developing only)?
Your response must be concise. -1.83. In the year 2004, what is the difference between the ODA received (in %) in High income: OECD and ODA received (in %) in Sub-Saharan Africa (developing only)?
Offer a very short reply. -25.62. In the year 2004, what is the difference between the ODA received (in %) of High income: OECD and ODA received (in %) of Croatia?
Make the answer very short. -1.04. In the year 2004, what is the difference between the ODA received (in %) in Latin America(developing only) and ODA received (in %) in Sub-Saharan Africa (developing only)?
Your answer should be compact. -23.79. In the year 2004, what is the difference between the ODA received (in %) of Latin America(developing only) and ODA received (in %) of Croatia?
Your response must be concise. 0.78. In the year 2004, what is the difference between the ODA received (in %) in Sub-Saharan Africa (developing only) and ODA received (in %) in Croatia?
Provide a succinct answer. 24.58. In the year 2005, what is the difference between the ODA received (in %) in High income: OECD and ODA received (in %) in Latin America(developing only)?
Ensure brevity in your answer.  -1.49. In the year 2005, what is the difference between the ODA received (in %) in High income: OECD and ODA received (in %) in Sub-Saharan Africa (developing only)?
Your answer should be compact. -27.73. In the year 2005, what is the difference between the ODA received (in %) of High income: OECD and ODA received (in %) of Croatia?
Make the answer very short. -0.97. In the year 2005, what is the difference between the ODA received (in %) in Latin America(developing only) and ODA received (in %) in Sub-Saharan Africa (developing only)?
Keep it short and to the point. -26.25. In the year 2005, what is the difference between the ODA received (in %) of Latin America(developing only) and ODA received (in %) of Croatia?
Your answer should be compact. 0.52. In the year 2005, what is the difference between the ODA received (in %) in Sub-Saharan Africa (developing only) and ODA received (in %) in Croatia?
Provide a succinct answer. 26.76. In the year 2006, what is the difference between the ODA received (in %) in High income: OECD and ODA received (in %) in Latin America(developing only)?
Offer a terse response. -1.34. In the year 2006, what is the difference between the ODA received (in %) in High income: OECD and ODA received (in %) in Sub-Saharan Africa (developing only)?
Your response must be concise. -28.61. In the year 2006, what is the difference between the ODA received (in %) of High income: OECD and ODA received (in %) of Croatia?
Provide a short and direct response. -1.35. In the year 2006, what is the difference between the ODA received (in %) of Latin America(developing only) and ODA received (in %) of Sub-Saharan Africa (developing only)?
Your answer should be very brief. -27.27. In the year 2006, what is the difference between the ODA received (in %) in Latin America(developing only) and ODA received (in %) in Croatia?
Your answer should be very brief. -0.01. In the year 2006, what is the difference between the ODA received (in %) of Sub-Saharan Africa (developing only) and ODA received (in %) of Croatia?
Your answer should be compact. 27.26. In the year 2007, what is the difference between the ODA received (in %) in High income: OECD and ODA received (in %) in Latin America(developing only)?
Provide a succinct answer. -1.03. In the year 2007, what is the difference between the ODA received (in %) of High income: OECD and ODA received (in %) of Sub-Saharan Africa (developing only)?
Your response must be concise. -20.13. In the year 2007, what is the difference between the ODA received (in %) of High income: OECD and ODA received (in %) of Croatia?
Your answer should be very brief. -0.91. In the year 2007, what is the difference between the ODA received (in %) in Latin America(developing only) and ODA received (in %) in Sub-Saharan Africa (developing only)?
Offer a very short reply. -19.1. In the year 2007, what is the difference between the ODA received (in %) in Latin America(developing only) and ODA received (in %) in Croatia?
Offer a terse response. 0.12. In the year 2007, what is the difference between the ODA received (in %) in Sub-Saharan Africa (developing only) and ODA received (in %) in Croatia?
Provide a short and direct response. 19.21. In the year 2008, what is the difference between the ODA received (in %) in High income: OECD and ODA received (in %) in Latin America(developing only)?
Offer a terse response. -1.12. In the year 2008, what is the difference between the ODA received (in %) in High income: OECD and ODA received (in %) in Sub-Saharan Africa (developing only)?
Keep it short and to the point. -19.35. In the year 2008, what is the difference between the ODA received (in %) of High income: OECD and ODA received (in %) of Croatia?
Your response must be concise. -1.09. In the year 2008, what is the difference between the ODA received (in %) in Latin America(developing only) and ODA received (in %) in Sub-Saharan Africa (developing only)?
Provide a short and direct response. -18.23. In the year 2008, what is the difference between the ODA received (in %) in Latin America(developing only) and ODA received (in %) in Croatia?
Make the answer very short. 0.03. In the year 2008, what is the difference between the ODA received (in %) of Sub-Saharan Africa (developing only) and ODA received (in %) of Croatia?
Offer a terse response. 18.26. What is the ratio of the ODA received (in %) in High income: OECD in 2001 to that in 2002?
Give a very brief answer. 4.45. What is the ratio of the ODA received (in %) of Latin America(developing only) in 2001 to that in 2002?
Provide a short and direct response. 1.11. What is the ratio of the ODA received (in %) of Sub-Saharan Africa (developing only) in 2001 to that in 2002?
Give a very brief answer. 0.82. What is the ratio of the ODA received (in %) of Croatia in 2001 to that in 2002?
Give a very brief answer. 1.17. What is the ratio of the ODA received (in %) in High income: OECD in 2001 to that in 2003?
Make the answer very short. 2.66. What is the ratio of the ODA received (in %) of Latin America(developing only) in 2001 to that in 2003?
Ensure brevity in your answer.  0.97. What is the ratio of the ODA received (in %) in Sub-Saharan Africa (developing only) in 2001 to that in 2003?
Your response must be concise. 0.87. What is the ratio of the ODA received (in %) of Croatia in 2001 to that in 2003?
Ensure brevity in your answer.  1.93. What is the ratio of the ODA received (in %) of High income: OECD in 2001 to that in 2004?
Your answer should be very brief. 4.75. What is the ratio of the ODA received (in %) of Latin America(developing only) in 2001 to that in 2004?
Your response must be concise. 1.01. What is the ratio of the ODA received (in %) of Sub-Saharan Africa (developing only) in 2001 to that in 2004?
Provide a short and direct response. 1.04. What is the ratio of the ODA received (in %) in Croatia in 2001 to that in 2004?
Keep it short and to the point. 2.3. What is the ratio of the ODA received (in %) of High income: OECD in 2001 to that in 2005?
Make the answer very short. 1.66. What is the ratio of the ODA received (in %) in Latin America(developing only) in 2001 to that in 2005?
Give a very brief answer. 1.24. What is the ratio of the ODA received (in %) of Sub-Saharan Africa (developing only) in 2001 to that in 2005?
Give a very brief answer. 0.96. What is the ratio of the ODA received (in %) of Croatia in 2001 to that in 2005?
Make the answer very short. 2.47. What is the ratio of the ODA received (in %) in High income: OECD in 2001 to that in 2006?
Provide a short and direct response. 2.95. What is the ratio of the ODA received (in %) of Latin America(developing only) in 2001 to that in 2006?
Your response must be concise. 1.37. What is the ratio of the ODA received (in %) in Sub-Saharan Africa (developing only) in 2001 to that in 2006?
Keep it short and to the point. 0.93. What is the ratio of the ODA received (in %) in Croatia in 2001 to that in 2006?
Provide a succinct answer. 1.77. What is the ratio of the ODA received (in %) of High income: OECD in 2001 to that in 2007?
Ensure brevity in your answer.  3.11. What is the ratio of the ODA received (in %) in Latin America(developing only) in 2001 to that in 2007?
Your response must be concise. 1.79. What is the ratio of the ODA received (in %) in Sub-Saharan Africa (developing only) in 2001 to that in 2007?
Your answer should be compact. 1.32. What is the ratio of the ODA received (in %) in Croatia in 2001 to that in 2007?
Ensure brevity in your answer.  2.63. What is the ratio of the ODA received (in %) of High income: OECD in 2001 to that in 2008?
Offer a very short reply. 3.11. What is the ratio of the ODA received (in %) of Latin America(developing only) in 2001 to that in 2008?
Provide a short and direct response. 1.64. What is the ratio of the ODA received (in %) of Sub-Saharan Africa (developing only) in 2001 to that in 2008?
Give a very brief answer. 1.37. What is the ratio of the ODA received (in %) in Croatia in 2001 to that in 2008?
Make the answer very short. 2.2. What is the ratio of the ODA received (in %) of High income: OECD in 2002 to that in 2003?
Give a very brief answer. 0.6. What is the ratio of the ODA received (in %) in Latin America(developing only) in 2002 to that in 2003?
Your answer should be compact. 0.87. What is the ratio of the ODA received (in %) in Sub-Saharan Africa (developing only) in 2002 to that in 2003?
Your answer should be compact. 1.06. What is the ratio of the ODA received (in %) of Croatia in 2002 to that in 2003?
Give a very brief answer. 1.65. What is the ratio of the ODA received (in %) of High income: OECD in 2002 to that in 2004?
Give a very brief answer. 1.07. What is the ratio of the ODA received (in %) in Latin America(developing only) in 2002 to that in 2004?
Provide a succinct answer. 0.91. What is the ratio of the ODA received (in %) in Sub-Saharan Africa (developing only) in 2002 to that in 2004?
Offer a terse response. 1.27. What is the ratio of the ODA received (in %) of Croatia in 2002 to that in 2004?
Offer a very short reply. 1.96. What is the ratio of the ODA received (in %) in High income: OECD in 2002 to that in 2005?
Your answer should be compact. 0.37. What is the ratio of the ODA received (in %) of Latin America(developing only) in 2002 to that in 2005?
Offer a terse response. 1.11. What is the ratio of the ODA received (in %) of Sub-Saharan Africa (developing only) in 2002 to that in 2005?
Your answer should be compact. 1.17. What is the ratio of the ODA received (in %) of Croatia in 2002 to that in 2005?
Make the answer very short. 2.11. What is the ratio of the ODA received (in %) in High income: OECD in 2002 to that in 2006?
Provide a short and direct response. 0.66. What is the ratio of the ODA received (in %) in Latin America(developing only) in 2002 to that in 2006?
Give a very brief answer. 1.23. What is the ratio of the ODA received (in %) of Sub-Saharan Africa (developing only) in 2002 to that in 2006?
Offer a very short reply. 1.13. What is the ratio of the ODA received (in %) in Croatia in 2002 to that in 2006?
Provide a succinct answer. 1.52. What is the ratio of the ODA received (in %) of High income: OECD in 2002 to that in 2007?
Keep it short and to the point. 0.7. What is the ratio of the ODA received (in %) in Latin America(developing only) in 2002 to that in 2007?
Ensure brevity in your answer.  1.61. What is the ratio of the ODA received (in %) of Sub-Saharan Africa (developing only) in 2002 to that in 2007?
Give a very brief answer. 1.61. What is the ratio of the ODA received (in %) in Croatia in 2002 to that in 2007?
Keep it short and to the point. 2.25. What is the ratio of the ODA received (in %) in High income: OECD in 2002 to that in 2008?
Provide a succinct answer. 0.7. What is the ratio of the ODA received (in %) in Latin America(developing only) in 2002 to that in 2008?
Provide a succinct answer. 1.48. What is the ratio of the ODA received (in %) of Sub-Saharan Africa (developing only) in 2002 to that in 2008?
Your answer should be compact. 1.68. What is the ratio of the ODA received (in %) in Croatia in 2002 to that in 2008?
Make the answer very short. 1.88. What is the ratio of the ODA received (in %) of High income: OECD in 2003 to that in 2004?
Make the answer very short. 1.79. What is the ratio of the ODA received (in %) in Latin America(developing only) in 2003 to that in 2004?
Your response must be concise. 1.04. What is the ratio of the ODA received (in %) of Sub-Saharan Africa (developing only) in 2003 to that in 2004?
Offer a terse response. 1.19. What is the ratio of the ODA received (in %) in Croatia in 2003 to that in 2004?
Provide a short and direct response. 1.19. What is the ratio of the ODA received (in %) of High income: OECD in 2003 to that in 2005?
Your answer should be compact. 0.62. What is the ratio of the ODA received (in %) in Latin America(developing only) in 2003 to that in 2005?
Your answer should be compact. 1.28. What is the ratio of the ODA received (in %) of Sub-Saharan Africa (developing only) in 2003 to that in 2005?
Offer a very short reply. 1.1. What is the ratio of the ODA received (in %) in Croatia in 2003 to that in 2005?
Make the answer very short. 1.28. What is the ratio of the ODA received (in %) in High income: OECD in 2003 to that in 2006?
Provide a short and direct response. 1.11. What is the ratio of the ODA received (in %) of Latin America(developing only) in 2003 to that in 2006?
Provide a short and direct response. 1.42. What is the ratio of the ODA received (in %) of Sub-Saharan Africa (developing only) in 2003 to that in 2006?
Ensure brevity in your answer.  1.07. What is the ratio of the ODA received (in %) in Croatia in 2003 to that in 2006?
Your answer should be very brief. 0.92. What is the ratio of the ODA received (in %) of High income: OECD in 2003 to that in 2007?
Offer a very short reply. 1.17. What is the ratio of the ODA received (in %) of Latin America(developing only) in 2003 to that in 2007?
Offer a terse response. 1.85. What is the ratio of the ODA received (in %) of Sub-Saharan Africa (developing only) in 2003 to that in 2007?
Offer a very short reply. 1.52. What is the ratio of the ODA received (in %) of Croatia in 2003 to that in 2007?
Your answer should be very brief. 1.36. What is the ratio of the ODA received (in %) in High income: OECD in 2003 to that in 2008?
Give a very brief answer. 1.17. What is the ratio of the ODA received (in %) of Latin America(developing only) in 2003 to that in 2008?
Ensure brevity in your answer.  1.7. What is the ratio of the ODA received (in %) of Sub-Saharan Africa (developing only) in 2003 to that in 2008?
Make the answer very short. 1.58. What is the ratio of the ODA received (in %) of Croatia in 2003 to that in 2008?
Offer a very short reply. 1.14. What is the ratio of the ODA received (in %) of High income: OECD in 2004 to that in 2005?
Give a very brief answer. 0.35. What is the ratio of the ODA received (in %) of Latin America(developing only) in 2004 to that in 2005?
Ensure brevity in your answer.  1.23. What is the ratio of the ODA received (in %) in Sub-Saharan Africa (developing only) in 2004 to that in 2005?
Keep it short and to the point. 0.92. What is the ratio of the ODA received (in %) in Croatia in 2004 to that in 2005?
Keep it short and to the point. 1.07. What is the ratio of the ODA received (in %) in High income: OECD in 2004 to that in 2006?
Your answer should be compact. 0.62. What is the ratio of the ODA received (in %) in Latin America(developing only) in 2004 to that in 2006?
Your answer should be compact. 1.36. What is the ratio of the ODA received (in %) of Sub-Saharan Africa (developing only) in 2004 to that in 2006?
Provide a succinct answer. 0.9. What is the ratio of the ODA received (in %) of Croatia in 2004 to that in 2006?
Offer a terse response. 0.77. What is the ratio of the ODA received (in %) in High income: OECD in 2004 to that in 2007?
Keep it short and to the point. 0.65. What is the ratio of the ODA received (in %) in Latin America(developing only) in 2004 to that in 2007?
Give a very brief answer. 1.78. What is the ratio of the ODA received (in %) of Sub-Saharan Africa (developing only) in 2004 to that in 2007?
Ensure brevity in your answer.  1.27. What is the ratio of the ODA received (in %) in Croatia in 2004 to that in 2007?
Provide a short and direct response. 1.15. What is the ratio of the ODA received (in %) in High income: OECD in 2004 to that in 2008?
Offer a terse response. 0.65. What is the ratio of the ODA received (in %) in Latin America(developing only) in 2004 to that in 2008?
Make the answer very short. 1.63. What is the ratio of the ODA received (in %) in Sub-Saharan Africa (developing only) in 2004 to that in 2008?
Offer a very short reply. 1.32. What is the ratio of the ODA received (in %) of Croatia in 2004 to that in 2008?
Give a very brief answer. 0.96. What is the ratio of the ODA received (in %) in High income: OECD in 2005 to that in 2006?
Provide a short and direct response. 1.77. What is the ratio of the ODA received (in %) in Latin America(developing only) in 2005 to that in 2006?
Your answer should be very brief. 1.11. What is the ratio of the ODA received (in %) in Sub-Saharan Africa (developing only) in 2005 to that in 2006?
Provide a short and direct response. 0.97. What is the ratio of the ODA received (in %) of Croatia in 2005 to that in 2006?
Give a very brief answer. 0.72. What is the ratio of the ODA received (in %) in High income: OECD in 2005 to that in 2007?
Keep it short and to the point. 1.87. What is the ratio of the ODA received (in %) of Latin America(developing only) in 2005 to that in 2007?
Your answer should be compact. 1.45. What is the ratio of the ODA received (in %) in Sub-Saharan Africa (developing only) in 2005 to that in 2007?
Keep it short and to the point. 1.38. What is the ratio of the ODA received (in %) of Croatia in 2005 to that in 2007?
Provide a short and direct response. 1.07. What is the ratio of the ODA received (in %) of High income: OECD in 2005 to that in 2008?
Offer a terse response. 1.87. What is the ratio of the ODA received (in %) in Latin America(developing only) in 2005 to that in 2008?
Provide a short and direct response. 1.33. What is the ratio of the ODA received (in %) of Sub-Saharan Africa (developing only) in 2005 to that in 2008?
Offer a very short reply. 1.43. What is the ratio of the ODA received (in %) of Croatia in 2005 to that in 2008?
Give a very brief answer. 0.89. What is the ratio of the ODA received (in %) in High income: OECD in 2006 to that in 2007?
Give a very brief answer. 1.06. What is the ratio of the ODA received (in %) in Latin America(developing only) in 2006 to that in 2007?
Offer a terse response. 1.31. What is the ratio of the ODA received (in %) in Sub-Saharan Africa (developing only) in 2006 to that in 2007?
Your answer should be very brief. 1.42. What is the ratio of the ODA received (in %) of Croatia in 2006 to that in 2007?
Ensure brevity in your answer.  1.48. What is the ratio of the ODA received (in %) in High income: OECD in 2006 to that in 2008?
Provide a succinct answer. 1.06. What is the ratio of the ODA received (in %) in Latin America(developing only) in 2006 to that in 2008?
Give a very brief answer. 1.2. What is the ratio of the ODA received (in %) in Sub-Saharan Africa (developing only) in 2006 to that in 2008?
Make the answer very short. 1.48. What is the ratio of the ODA received (in %) in Croatia in 2006 to that in 2008?
Your response must be concise. 1.24. What is the ratio of the ODA received (in %) in High income: OECD in 2007 to that in 2008?
Ensure brevity in your answer.  1. What is the ratio of the ODA received (in %) in Latin America(developing only) in 2007 to that in 2008?
Give a very brief answer. 0.92. What is the ratio of the ODA received (in %) in Sub-Saharan Africa (developing only) in 2007 to that in 2008?
Your response must be concise. 1.04. What is the ratio of the ODA received (in %) in Croatia in 2007 to that in 2008?
Offer a very short reply. 0.84. What is the difference between the highest and the second highest ODA received (in %) of High income: OECD?
Provide a succinct answer. 0. What is the difference between the highest and the second highest ODA received (in %) in Latin America(developing only)?
Keep it short and to the point. 0.06. What is the difference between the highest and the second highest ODA received (in %) of Sub-Saharan Africa (developing only)?
Offer a very short reply. 1.96. What is the difference between the highest and the second highest ODA received (in %) in Croatia?
Your answer should be very brief. 0.35. What is the difference between the highest and the lowest ODA received (in %) in High income: OECD?
Offer a terse response. 0. What is the difference between the highest and the lowest ODA received (in %) in Latin America(developing only)?
Give a very brief answer. 0.88. What is the difference between the highest and the lowest ODA received (in %) of Sub-Saharan Africa (developing only)?
Your answer should be very brief. 13.1. What is the difference between the highest and the lowest ODA received (in %) of Croatia?
Keep it short and to the point. 1.49. 